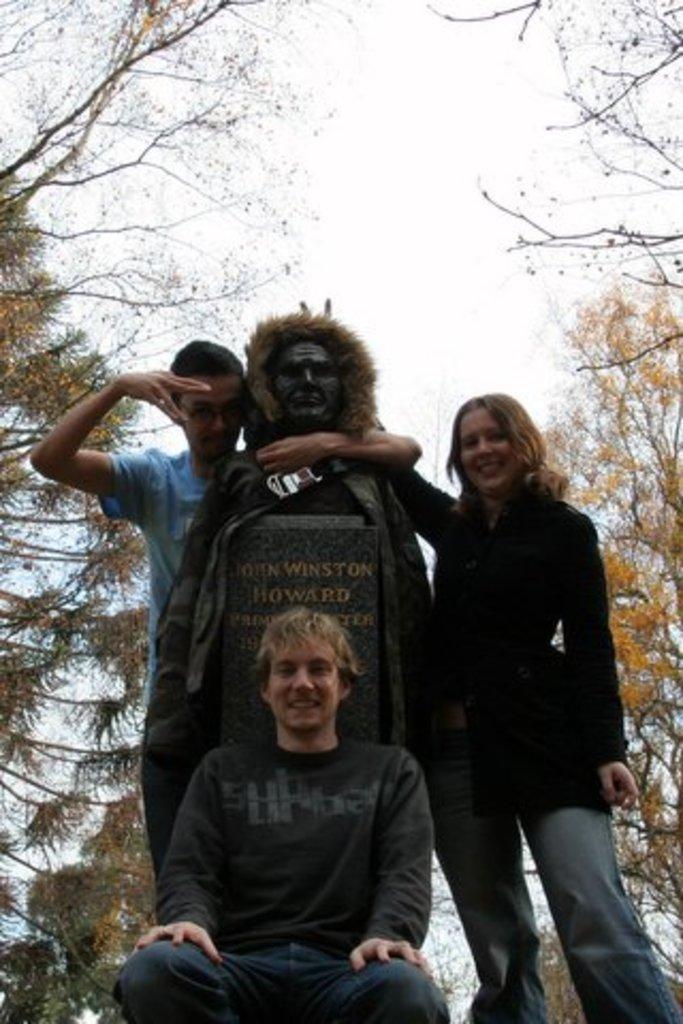In one or two sentences, can you explain what this image depicts? In the center of the image there is a statue. There are people standing beside it. At the bottom of the image there is a person in squat position. In the background of the image there are trees. There is sky. 